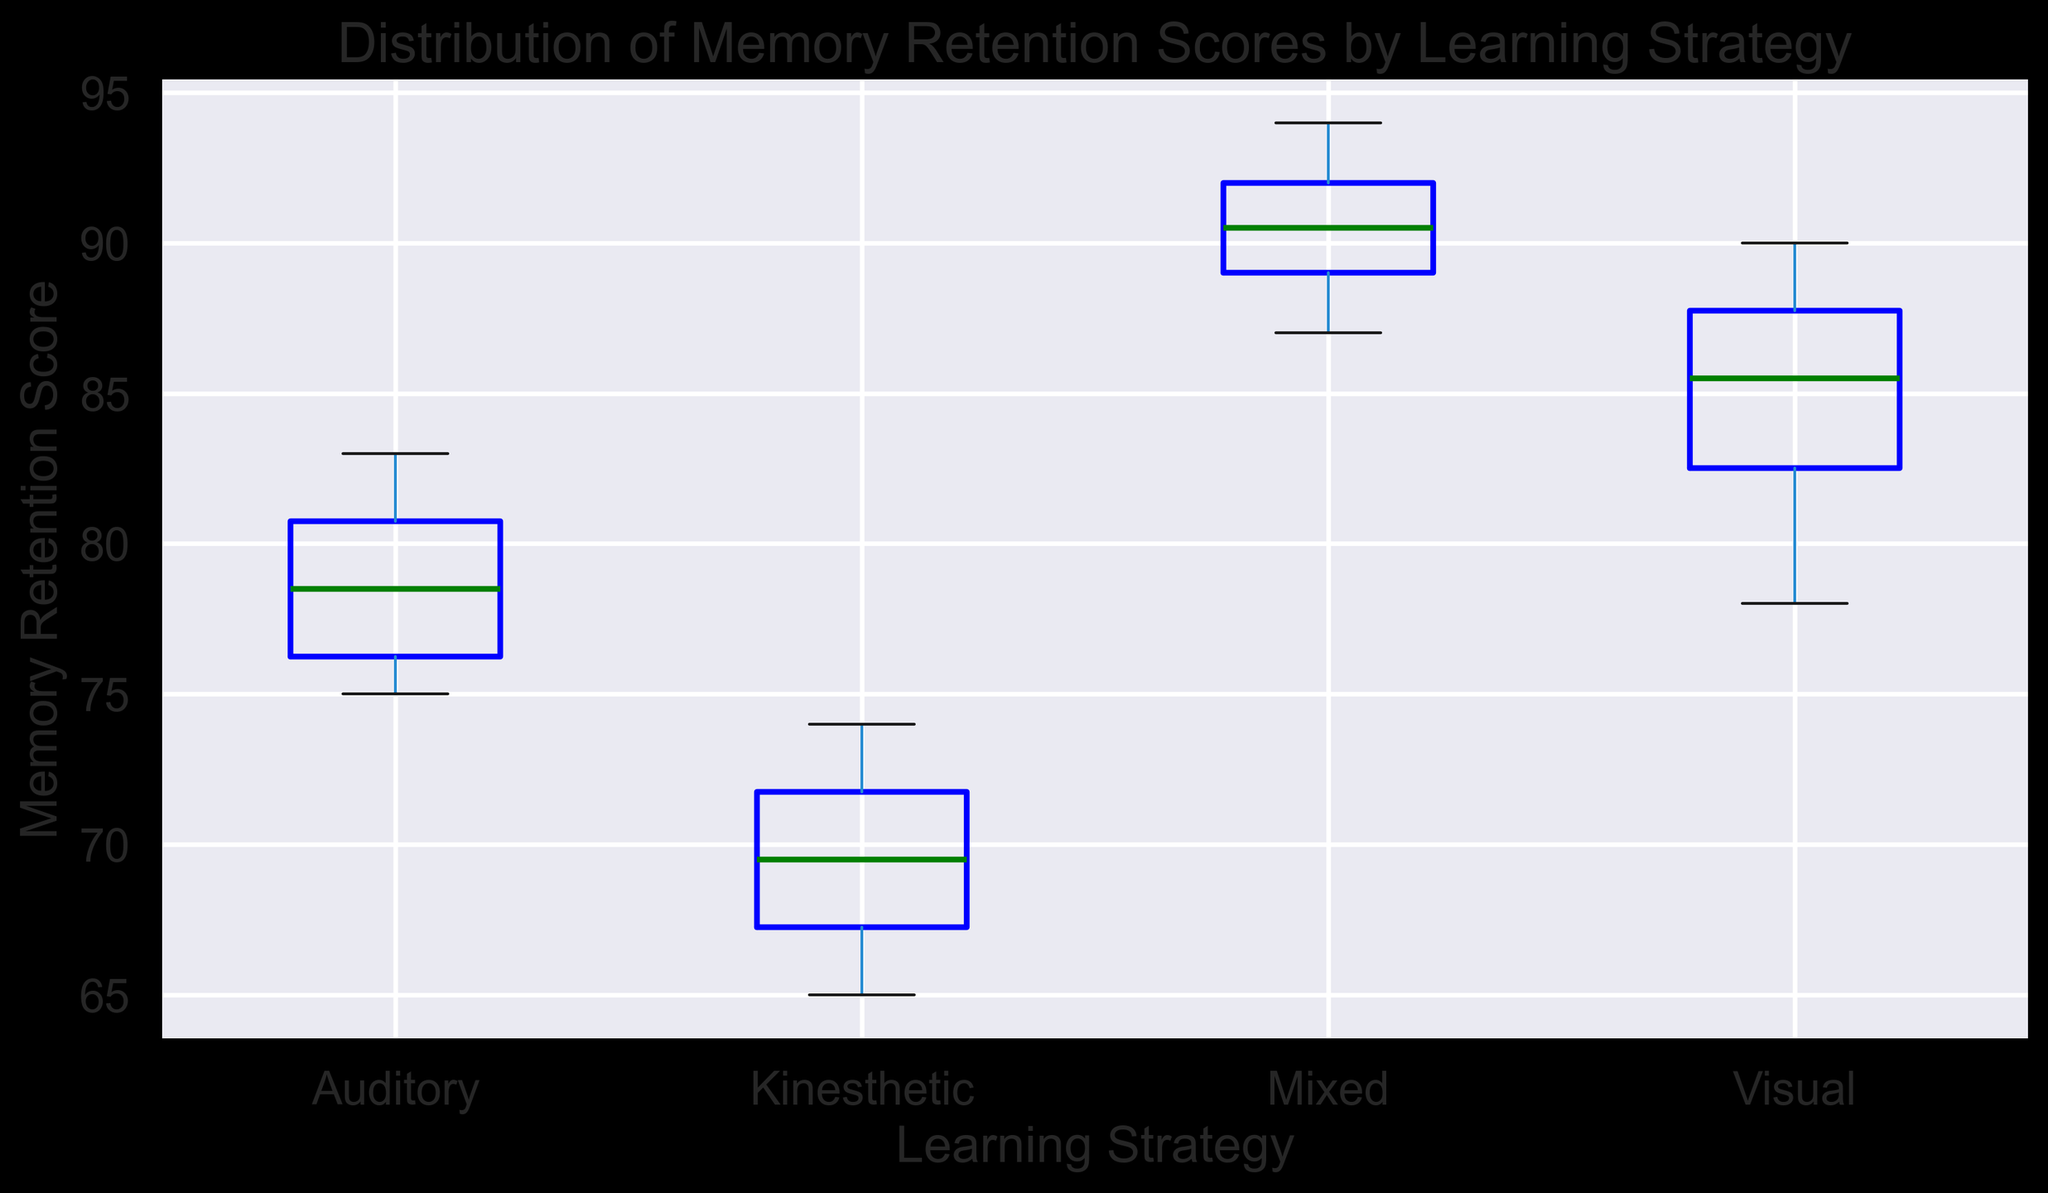What is the median memory retention score for the Auditory learning strategy? Look at the middle line in the Auditory box plot, which represents the median.
Answer: 79 Which learning strategy has the highest median memory retention score? Identify the median lines for all box plots and compare them. The Mixed learning strategy has the highest median.
Answer: Mixed Is the interquartile range (IQR) larger for the Visual or Kinesthetic learning strategy? The IQR is represented by the length of the box. Compare the height of the boxes for Visual and Kinesthetic. The Kinesthetic box is taller, indicating a larger IQR.
Answer: Kinesthetic Which learning strategy has the lowest minimum memory retention score? Find the lowest point (whisker) for each box plot and compare. The Kinesthetic strategy has the lowest minimum score.
Answer: Kinesthetic What is the range of memory retention scores for the Visual learning strategy? The range is the difference between the maximum and minimum values. For Visual, the minimum is 78, and the maximum is 90, so the range is 90 - 78.
Answer: 12 How does the spread of memory retention scores for Auditory compare to Visual? Look at the length of the boxes and whiskers for both strategies. The spread is similar but slightly narrower for Auditory than for Visual, indicating more variability in the Visual scores.
Answer: Visual has more spread Which learning strategy has the smallest interquartile range (IQR)? The IQR is the length of the box. Compare all boxes and identify the one with the smallest IQR. The Mixed learning strategy has the smallest IQR.
Answer: Mixed Are there any outliers in the memory retention scores for the Kinesthetic learning strategy? Outliers are indicated by red markers outside the whiskers. The Kinesthetic plot does not have red markers outside the whiskers.
Answer: No What is the difference between the medians of the Visual and Kinesthetic learning strategies? Find the median values for both Visual and Kinesthetic and then subtract the lower value from the higher value. Visual median is 85, and Kinesthetic median is 70, so the difference is 85 - 70.
Answer: 15 